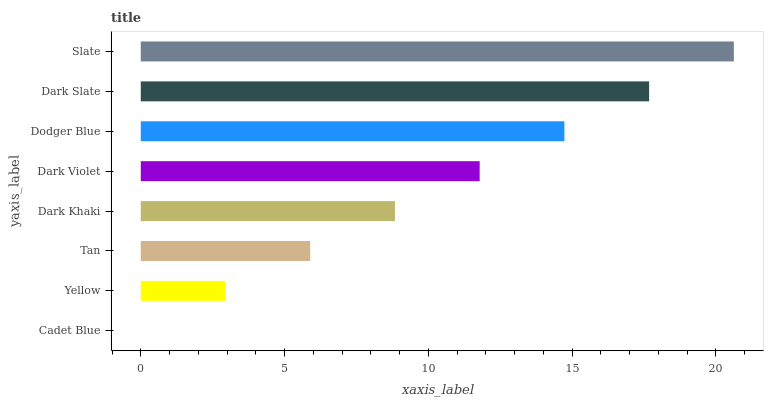Is Cadet Blue the minimum?
Answer yes or no. Yes. Is Slate the maximum?
Answer yes or no. Yes. Is Yellow the minimum?
Answer yes or no. No. Is Yellow the maximum?
Answer yes or no. No. Is Yellow greater than Cadet Blue?
Answer yes or no. Yes. Is Cadet Blue less than Yellow?
Answer yes or no. Yes. Is Cadet Blue greater than Yellow?
Answer yes or no. No. Is Yellow less than Cadet Blue?
Answer yes or no. No. Is Dark Violet the high median?
Answer yes or no. Yes. Is Dark Khaki the low median?
Answer yes or no. Yes. Is Tan the high median?
Answer yes or no. No. Is Cadet Blue the low median?
Answer yes or no. No. 